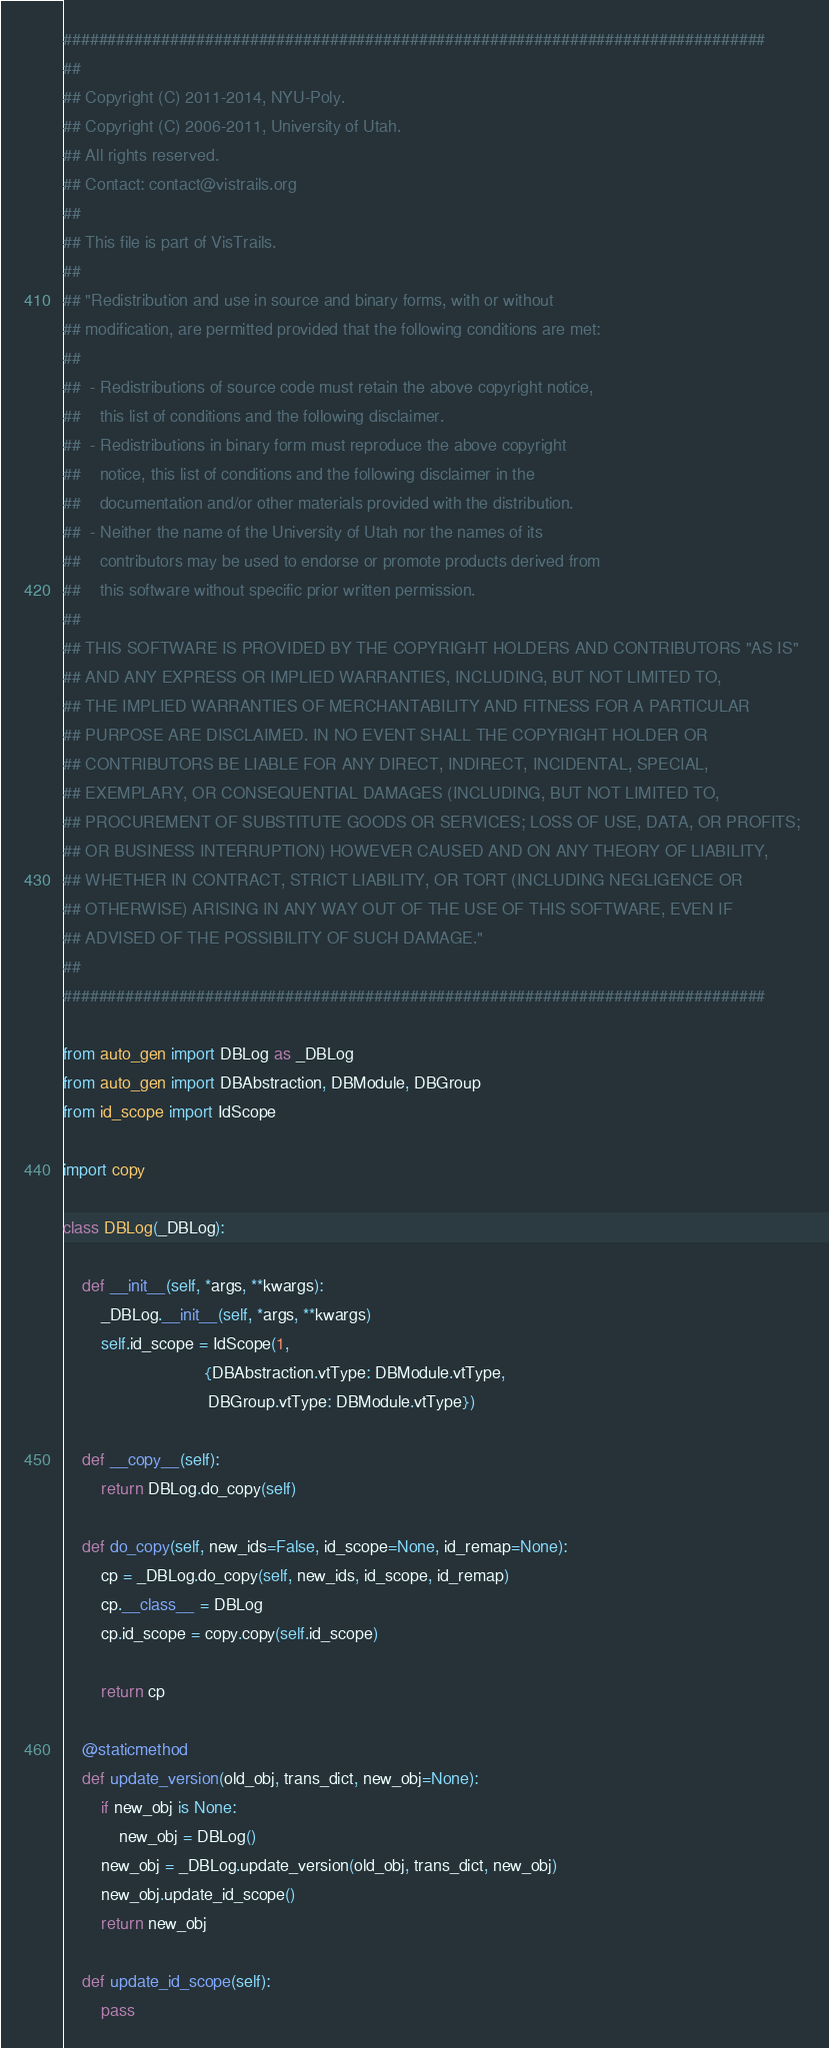<code> <loc_0><loc_0><loc_500><loc_500><_Python_>###############################################################################
##
## Copyright (C) 2011-2014, NYU-Poly.
## Copyright (C) 2006-2011, University of Utah. 
## All rights reserved.
## Contact: contact@vistrails.org
##
## This file is part of VisTrails.
##
## "Redistribution and use in source and binary forms, with or without 
## modification, are permitted provided that the following conditions are met:
##
##  - Redistributions of source code must retain the above copyright notice, 
##    this list of conditions and the following disclaimer.
##  - Redistributions in binary form must reproduce the above copyright 
##    notice, this list of conditions and the following disclaimer in the 
##    documentation and/or other materials provided with the distribution.
##  - Neither the name of the University of Utah nor the names of its 
##    contributors may be used to endorse or promote products derived from 
##    this software without specific prior written permission.
##
## THIS SOFTWARE IS PROVIDED BY THE COPYRIGHT HOLDERS AND CONTRIBUTORS "AS IS" 
## AND ANY EXPRESS OR IMPLIED WARRANTIES, INCLUDING, BUT NOT LIMITED TO, 
## THE IMPLIED WARRANTIES OF MERCHANTABILITY AND FITNESS FOR A PARTICULAR 
## PURPOSE ARE DISCLAIMED. IN NO EVENT SHALL THE COPYRIGHT HOLDER OR 
## CONTRIBUTORS BE LIABLE FOR ANY DIRECT, INDIRECT, INCIDENTAL, SPECIAL, 
## EXEMPLARY, OR CONSEQUENTIAL DAMAGES (INCLUDING, BUT NOT LIMITED TO, 
## PROCUREMENT OF SUBSTITUTE GOODS OR SERVICES; LOSS OF USE, DATA, OR PROFITS; 
## OR BUSINESS INTERRUPTION) HOWEVER CAUSED AND ON ANY THEORY OF LIABILITY, 
## WHETHER IN CONTRACT, STRICT LIABILITY, OR TORT (INCLUDING NEGLIGENCE OR 
## OTHERWISE) ARISING IN ANY WAY OUT OF THE USE OF THIS SOFTWARE, EVEN IF 
## ADVISED OF THE POSSIBILITY OF SUCH DAMAGE."
##
###############################################################################

from auto_gen import DBLog as _DBLog
from auto_gen import DBAbstraction, DBModule, DBGroup
from id_scope import IdScope

import copy

class DBLog(_DBLog):

    def __init__(self, *args, **kwargs):
        _DBLog.__init__(self, *args, **kwargs)
        self.id_scope = IdScope(1,
                              {DBAbstraction.vtType: DBModule.vtType,
                               DBGroup.vtType: DBModule.vtType})

    def __copy__(self):
        return DBLog.do_copy(self)

    def do_copy(self, new_ids=False, id_scope=None, id_remap=None):
        cp = _DBLog.do_copy(self, new_ids, id_scope, id_remap)
        cp.__class__ = DBLog
        cp.id_scope = copy.copy(self.id_scope)
        
        return cp

    @staticmethod
    def update_version(old_obj, trans_dict, new_obj=None):
        if new_obj is None:
            new_obj = DBLog()
        new_obj = _DBLog.update_version(old_obj, trans_dict, new_obj)
        new_obj.update_id_scope()
        return new_obj

    def update_id_scope(self):
        pass
</code> 